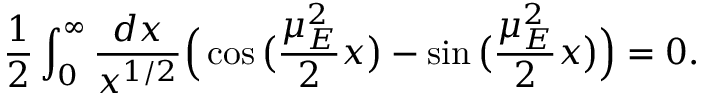<formula> <loc_0><loc_0><loc_500><loc_500>\frac { 1 } { 2 } \int _ { 0 } ^ { \infty } \frac { d x } { x ^ { 1 / 2 } } \left ( \cos \left ( \frac { \mu _ { E } ^ { 2 } } { 2 } x \right ) - \sin \left ( \frac { \mu _ { E } ^ { 2 } } { 2 } x \right ) \right ) = 0 .</formula> 